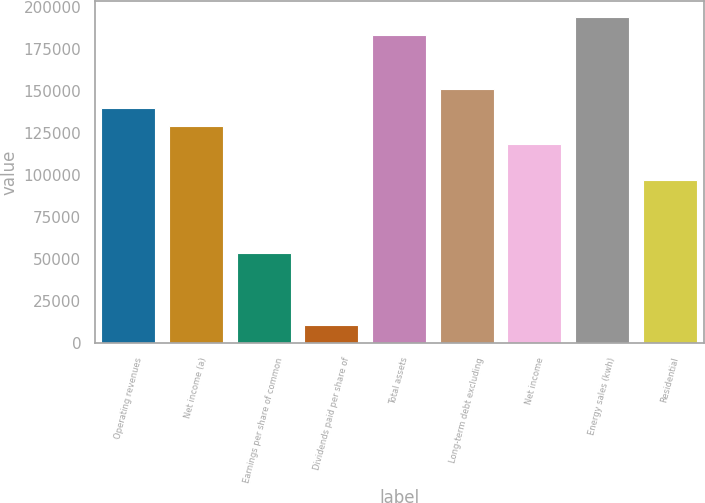<chart> <loc_0><loc_0><loc_500><loc_500><bar_chart><fcel>Operating revenues<fcel>Net income (a)<fcel>Earnings per share of common<fcel>Dividends paid per share of<fcel>Total assets<fcel>Long-term debt excluding<fcel>Net income<fcel>Energy sales (kwh)<fcel>Residential<nl><fcel>140371<fcel>129573<fcel>53989.4<fcel>10798.5<fcel>183562<fcel>151169<fcel>118776<fcel>194360<fcel>97180.3<nl></chart> 